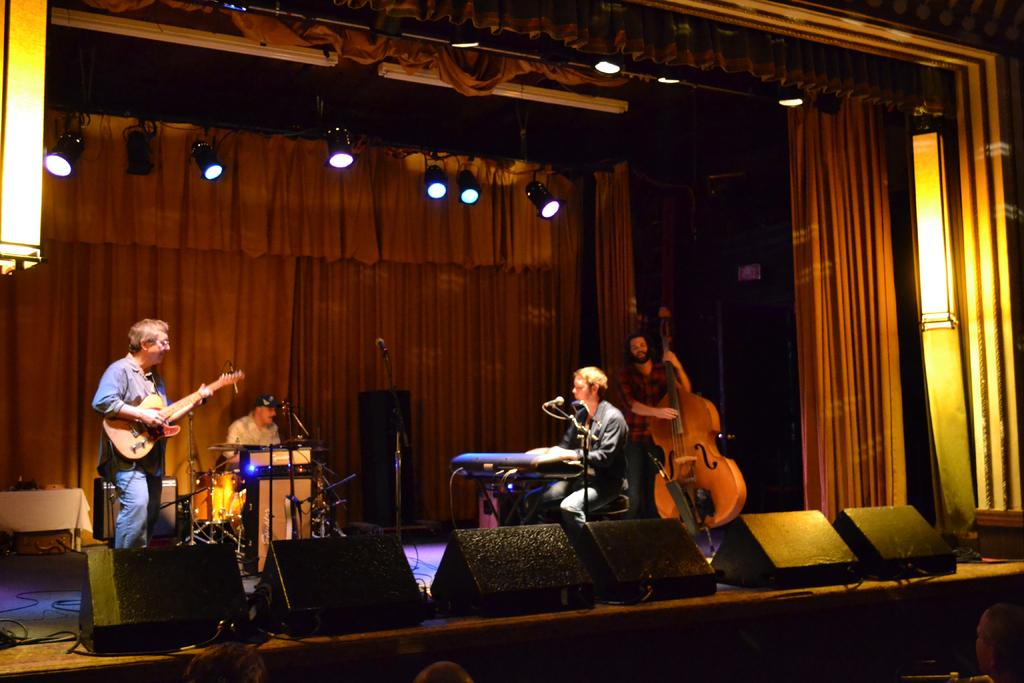What can be seen in the image related to illumination? There are lights in the image. What type of window treatment is present in the image? There are curtains in the image. How many people are on stage in the image? There are four people on stage in the image. What instruments are the two men on the sides holding? The man on the left side is holding a guitar, and the man on the right side is also holding a guitar. What are the two men holding guitars sitting on? These two people are sitting on chairs. How many eggs are being carried by the cows in the image? There are no cows or eggs present in the image. What type of donkey can be seen playing a musical instrument in the image? There is no donkey or musical instrument present in the image. 